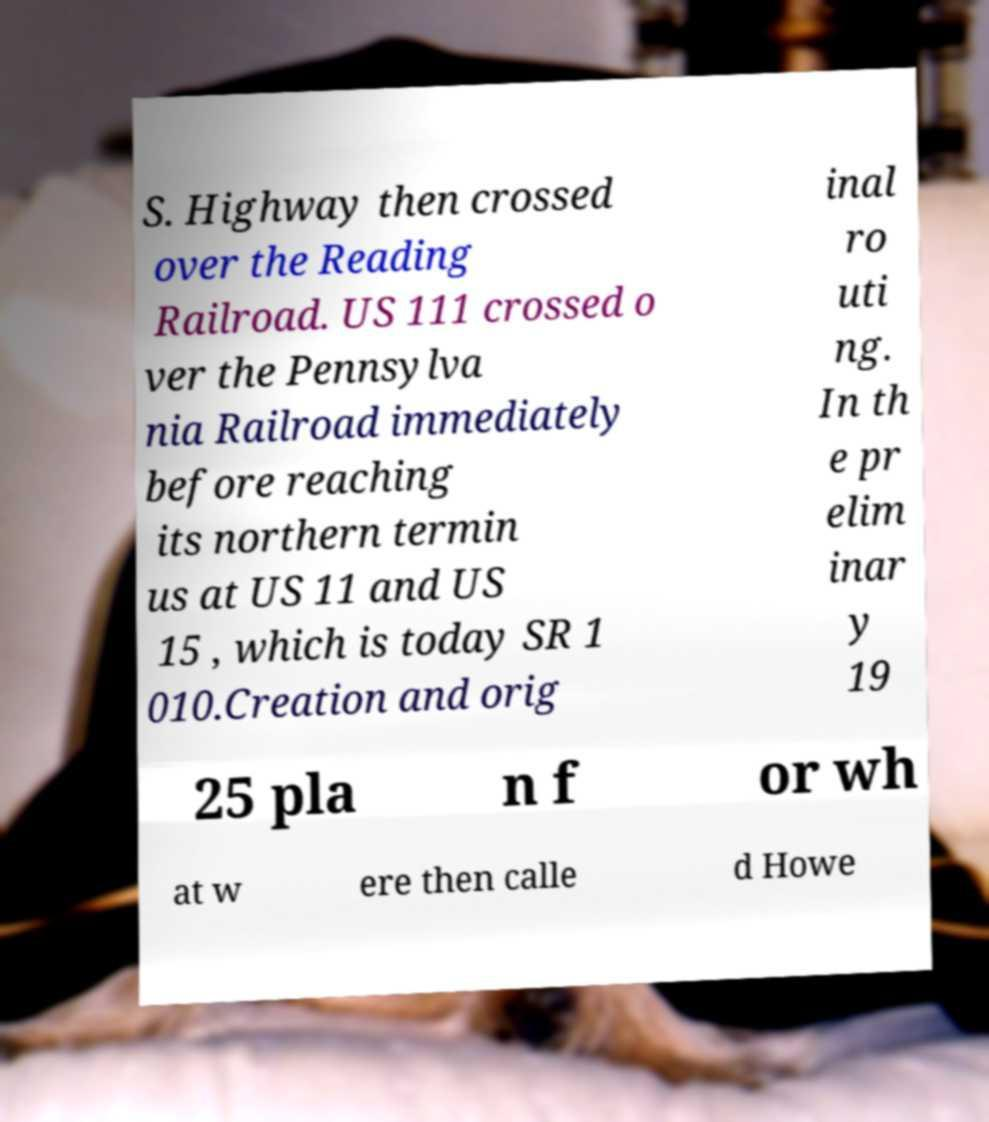Can you read and provide the text displayed in the image?This photo seems to have some interesting text. Can you extract and type it out for me? S. Highway then crossed over the Reading Railroad. US 111 crossed o ver the Pennsylva nia Railroad immediately before reaching its northern termin us at US 11 and US 15 , which is today SR 1 010.Creation and orig inal ro uti ng. In th e pr elim inar y 19 25 pla n f or wh at w ere then calle d Howe 